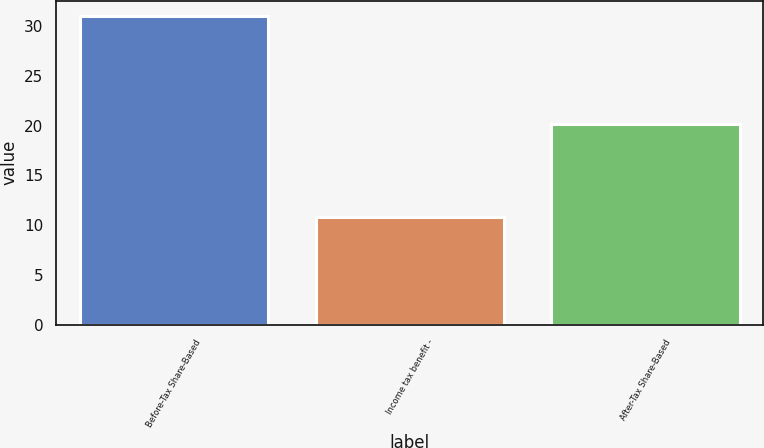Convert chart to OTSL. <chart><loc_0><loc_0><loc_500><loc_500><bar_chart><fcel>Before-Tax Share-Based<fcel>Income tax benefit -<fcel>After-Tax Share-Based<nl><fcel>31<fcel>10.8<fcel>20.2<nl></chart> 